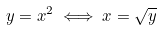<formula> <loc_0><loc_0><loc_500><loc_500>y = x ^ { 2 } \iff x = \sqrt { y }</formula> 